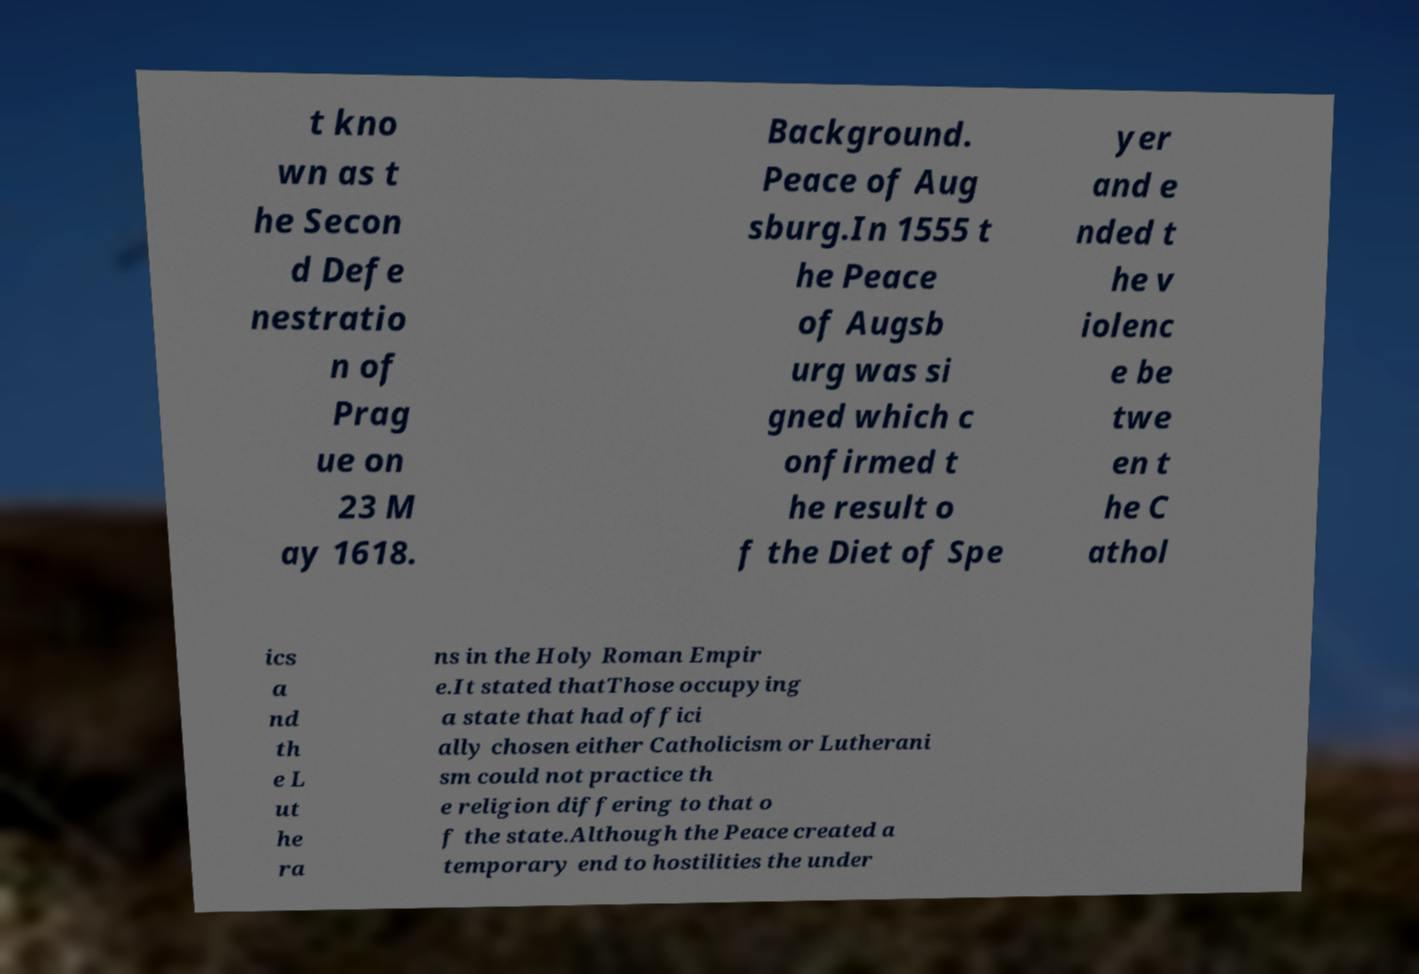Can you read and provide the text displayed in the image?This photo seems to have some interesting text. Can you extract and type it out for me? t kno wn as t he Secon d Defe nestratio n of Prag ue on 23 M ay 1618. Background. Peace of Aug sburg.In 1555 t he Peace of Augsb urg was si gned which c onfirmed t he result o f the Diet of Spe yer and e nded t he v iolenc e be twe en t he C athol ics a nd th e L ut he ra ns in the Holy Roman Empir e.It stated thatThose occupying a state that had offici ally chosen either Catholicism or Lutherani sm could not practice th e religion differing to that o f the state.Although the Peace created a temporary end to hostilities the under 